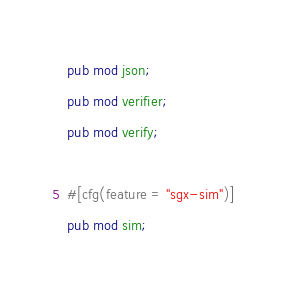Convert code to text. <code><loc_0><loc_0><loc_500><loc_500><_Rust_>
pub mod json;
pub mod verifier;
pub mod verify;

#[cfg(feature = "sgx-sim")]
pub mod sim;
</code> 